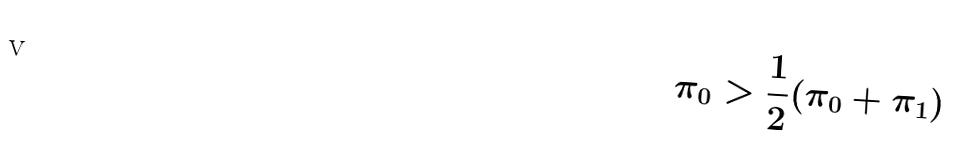<formula> <loc_0><loc_0><loc_500><loc_500>\pi _ { 0 } > \frac { 1 } { 2 } ( \pi _ { 0 } + \pi _ { 1 } )</formula> 